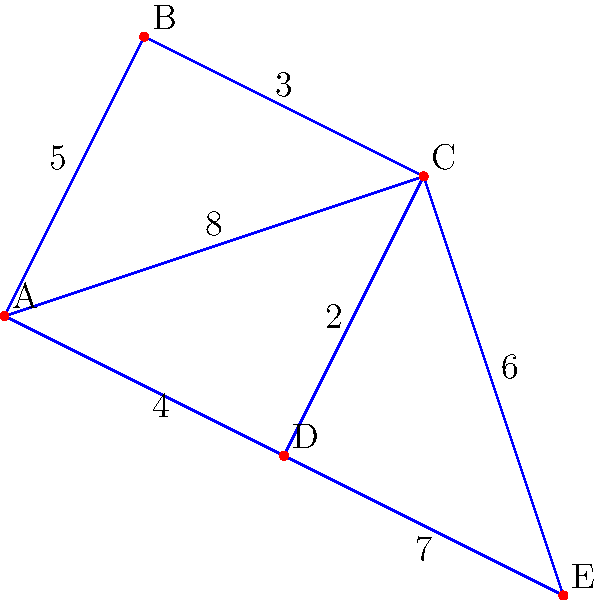A delivery service needs to plan the most efficient route from point A to point E in the given network. Each edge represents a road, and the numbers indicate the time (in minutes) to travel that road. What is the shortest time to reach point E from point A? To find the shortest time from A to E, we'll use Dijkstra's algorithm, which is practical for finding the shortest path in a weighted graph. Here's a step-by-step approach:

1. Initialize:
   - Set A's distance to 0 and all other vertices to infinity.
   - Mark all vertices as unvisited.

2. For the current vertex (starting with A), consider all unvisited neighbors and calculate their tentative distances.
   - A to B: 5 minutes
   - A to C: 8 minutes
   - A to D: 4 minutes

3. Mark A as visited. The current shortest paths are:
   - A to B: 5 minutes
   - A to C: 8 minutes
   - A to D: 4 minutes
   - A to E: infinity

4. Select the unvisited vertex with the smallest tentative distance (D) and repeat step 2:
   - D to C: 4 + 2 = 6 minutes (shorter than current C, so update)
   - D to E: 4 + 7 = 11 minutes

5. Mark D as visited. Current shortest paths:
   - A to B: 5 minutes
   - A to C: 6 minutes (via D)
   - A to D: 4 minutes
   - A to E: 11 minutes (via D)

6. Select B (next shortest unvisited) and repeat:
   - B to C: 5 + 3 = 8 minutes (longer than current C, so ignore)

7. Mark B as visited. No changes to shortest paths.

8. Select C and repeat:
   - C to E: 6 + 6 = 12 minutes (longer than current E, so ignore)

9. Mark C as visited. The shortest path to E is already found (11 minutes via A-D-E).

Therefore, the shortest time to reach E from A is 11 minutes.
Answer: 11 minutes 